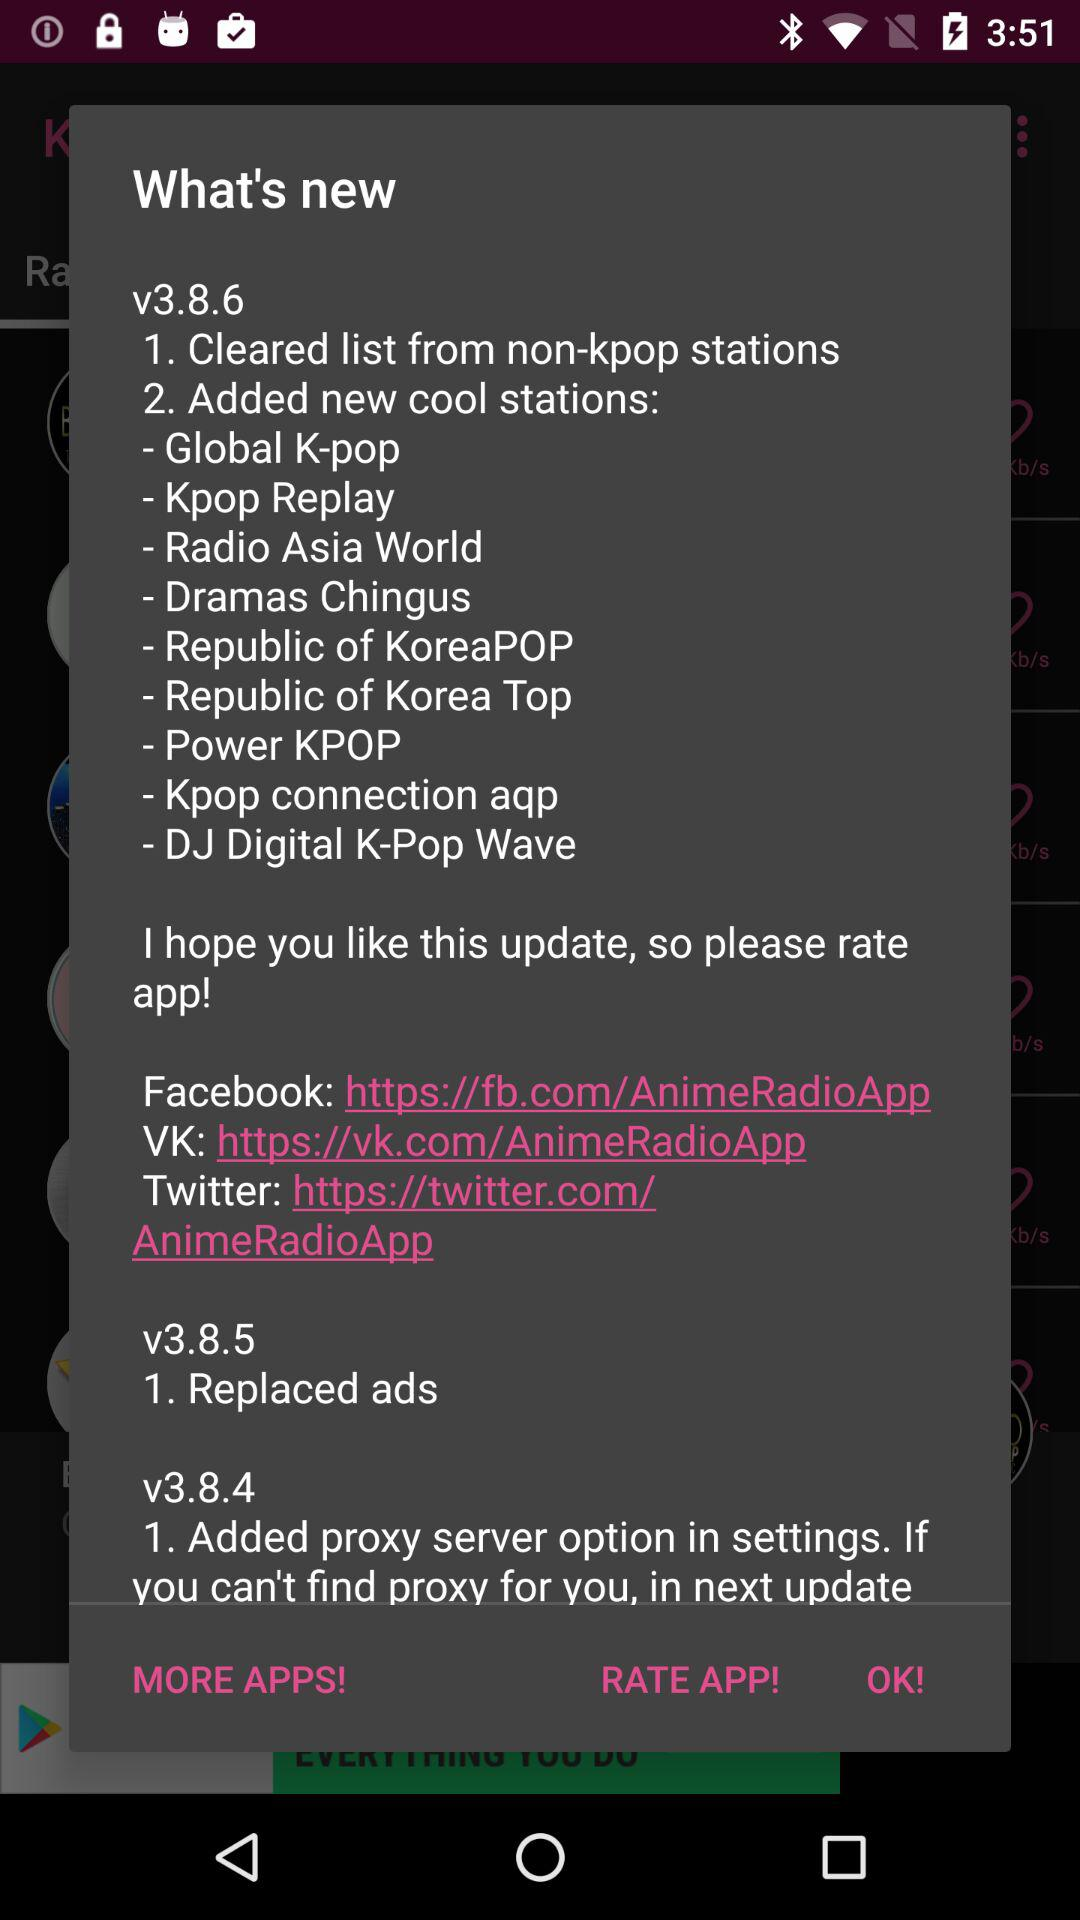What are the different available versions of the application? The different available versions are v3.8.6, v3.8.5 and v3.8.4. 